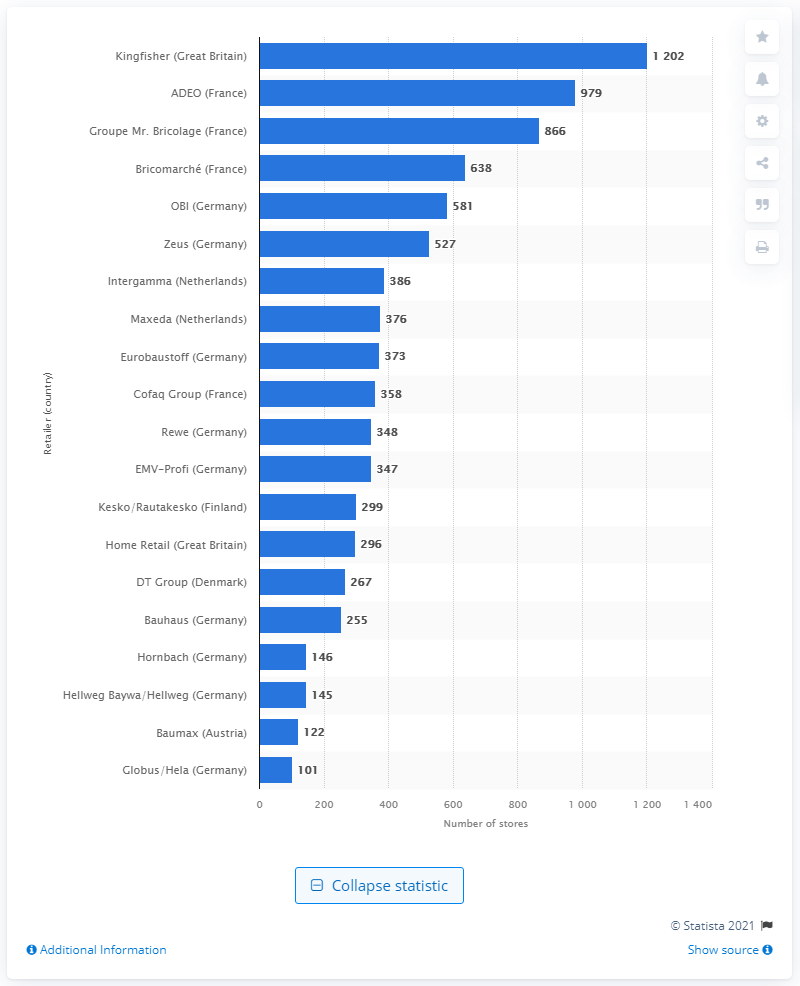How many stores did Kingfisher operate in 2014? In 2014, Kingfisher operated a total of 1,202 stores. Kingfisher is a prominent home improvement company in Great Britain, and their extensive network of stores reflects their market presence during that year. 